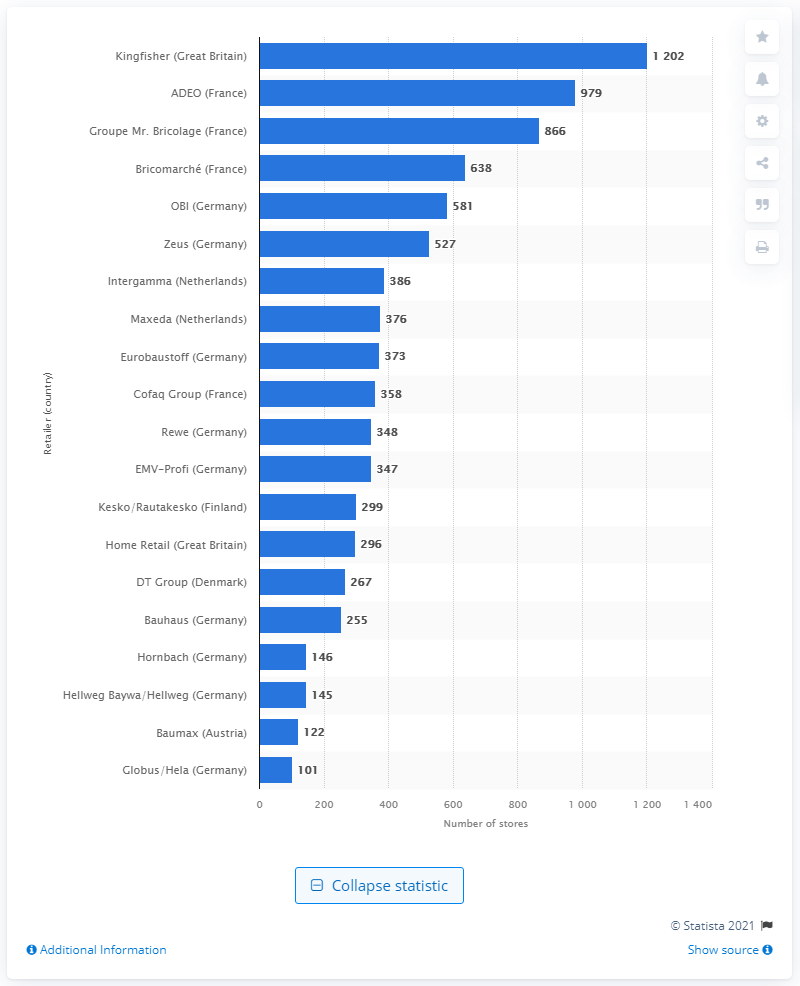How many stores did Kingfisher operate in 2014? In 2014, Kingfisher operated a total of 1,202 stores. Kingfisher is a prominent home improvement company in Great Britain, and their extensive network of stores reflects their market presence during that year. 